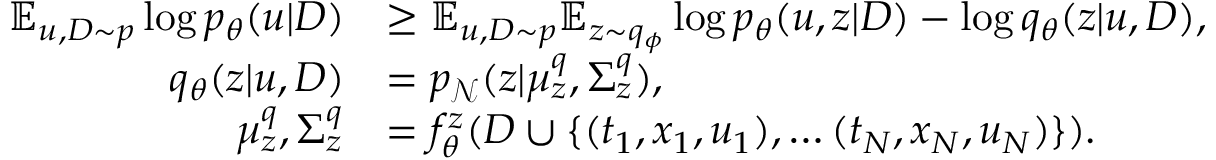Convert formula to latex. <formula><loc_0><loc_0><loc_500><loc_500>\begin{array} { r l } { \mathbb { E } _ { u , D \sim p } \log p _ { \theta } ( u | D ) } & { \geq \mathbb { E } _ { u , D \sim p } \mathbb { E } _ { z \sim q _ { \phi } } \log p _ { \theta } ( u , z | D ) - \log q _ { \theta } ( z | u , D ) , } \\ { q _ { \theta } ( z | u , D ) } & { = p _ { \mathcal { N } } ( z | \mu _ { z } ^ { q } , \Sigma _ { z } ^ { q } ) , } \\ { \mu _ { z } ^ { q } , \Sigma _ { z } ^ { q } } & { = f _ { \theta } ^ { z } ( D \cup \{ ( t _ { 1 } , x _ { 1 } , u _ { 1 } ) , \dots ( t _ { N } , x _ { N } , u _ { N } ) \} ) . } \end{array}</formula> 